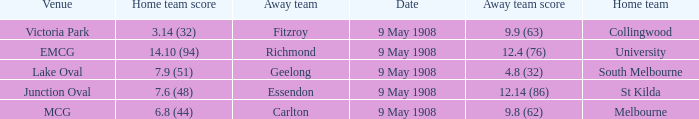Name the away team score for lake oval 4.8 (32). Give me the full table as a dictionary. {'header': ['Venue', 'Home team score', 'Away team', 'Date', 'Away team score', 'Home team'], 'rows': [['Victoria Park', '3.14 (32)', 'Fitzroy', '9 May 1908', '9.9 (63)', 'Collingwood'], ['EMCG', '14.10 (94)', 'Richmond', '9 May 1908', '12.4 (76)', 'University'], ['Lake Oval', '7.9 (51)', 'Geelong', '9 May 1908', '4.8 (32)', 'South Melbourne'], ['Junction Oval', '7.6 (48)', 'Essendon', '9 May 1908', '12.14 (86)', 'St Kilda'], ['MCG', '6.8 (44)', 'Carlton', '9 May 1908', '9.8 (62)', 'Melbourne']]} 